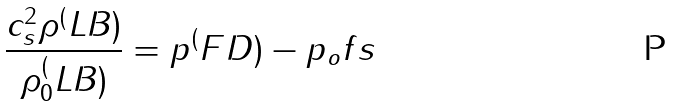Convert formula to latex. <formula><loc_0><loc_0><loc_500><loc_500>\frac { c _ { s } ^ { 2 } \rho ^ { ( } L B ) } { \rho _ { 0 } ^ { ( } L B ) } = p ^ { ( } F D ) - p _ { o } f s</formula> 